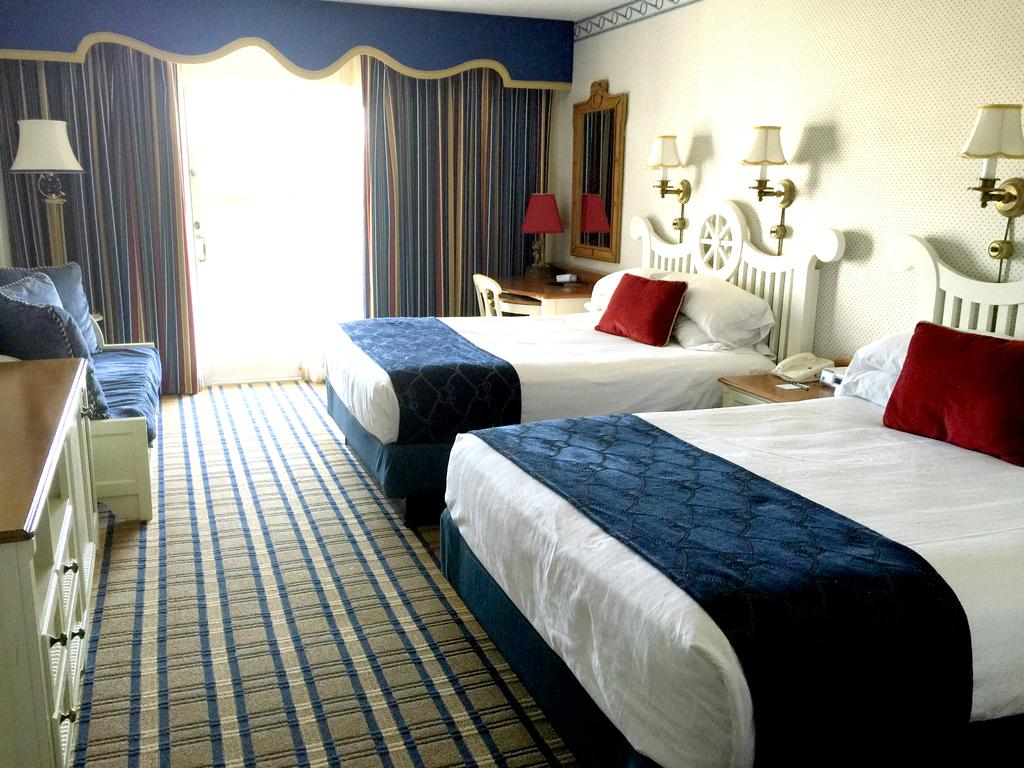How many beds are visible in the image? There are two beds in the image. What can be found on top of the beds? There are pillows on the beds. Can you describe the lighting fixture in the image? There is a lamp on the wall. How many curtains are present in the image? There are two curtains in the image. What type of furniture is present in the image that can be used for storage? There are drawers in the image. What type of lace is used to decorate the curtains in the image? There is no lace present on the curtains in the image; they are plain. What type of beast can be seen hiding under one of the beds in the image? There are no beasts present in the image; it is a room with two beds, pillows, a lamp, curtains, and drawers. 